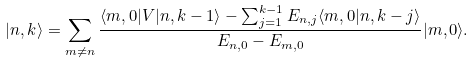Convert formula to latex. <formula><loc_0><loc_0><loc_500><loc_500>| n , k \rangle = \sum _ { m \ne n } \frac { \langle m , 0 | V | n , k - 1 \rangle - \sum _ { j = 1 } ^ { k - 1 } E _ { n , j } \langle m , 0 | n , k - j \rangle } { E _ { n , 0 } - E _ { m , 0 } } | m , 0 \rangle .</formula> 